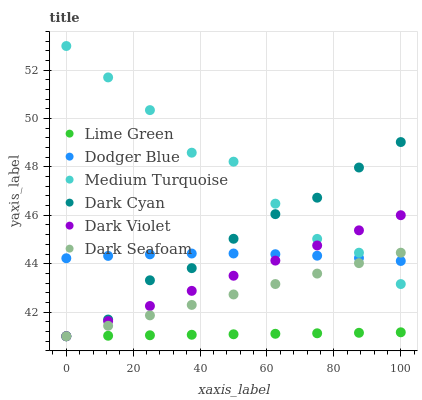Does Lime Green have the minimum area under the curve?
Answer yes or no. Yes. Does Medium Turquoise have the maximum area under the curve?
Answer yes or no. Yes. Does Dark Seafoam have the minimum area under the curve?
Answer yes or no. No. Does Dark Seafoam have the maximum area under the curve?
Answer yes or no. No. Is Lime Green the smoothest?
Answer yes or no. Yes. Is Medium Turquoise the roughest?
Answer yes or no. Yes. Is Dark Seafoam the smoothest?
Answer yes or no. No. Is Dark Seafoam the roughest?
Answer yes or no. No. Does Dark Violet have the lowest value?
Answer yes or no. Yes. Does Dodger Blue have the lowest value?
Answer yes or no. No. Does Medium Turquoise have the highest value?
Answer yes or no. Yes. Does Dark Seafoam have the highest value?
Answer yes or no. No. Is Lime Green less than Medium Turquoise?
Answer yes or no. Yes. Is Medium Turquoise greater than Lime Green?
Answer yes or no. Yes. Does Dark Seafoam intersect Dodger Blue?
Answer yes or no. Yes. Is Dark Seafoam less than Dodger Blue?
Answer yes or no. No. Is Dark Seafoam greater than Dodger Blue?
Answer yes or no. No. Does Lime Green intersect Medium Turquoise?
Answer yes or no. No. 